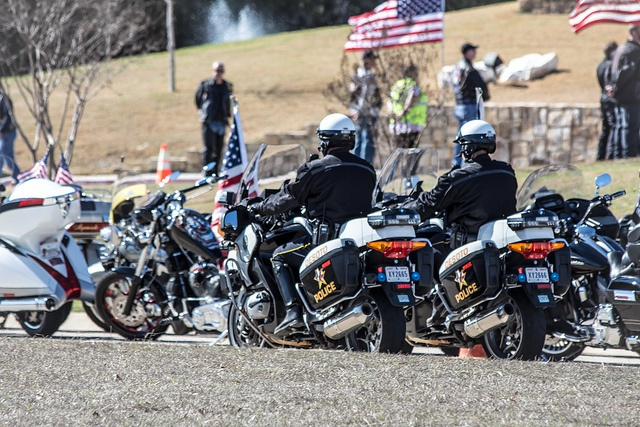Describe the objects in this image and their specific colors. I can see motorcycle in gray, black, white, and darkgray tones, motorcycle in gray, black, darkgray, and lightgray tones, motorcycle in gray, black, darkgray, and lightgray tones, motorcycle in gray, lightgray, black, and darkgray tones, and people in gray, black, navy, and darkgray tones in this image. 